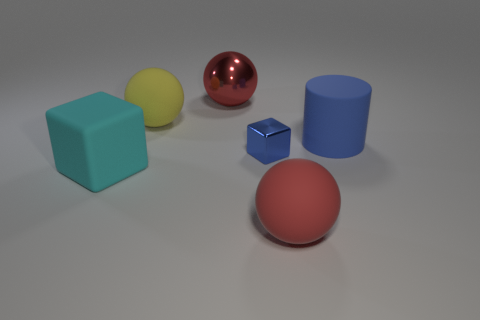Add 1 tiny brown rubber spheres. How many objects exist? 7 Subtract all cylinders. How many objects are left? 5 Subtract all large blue cylinders. Subtract all big blue cylinders. How many objects are left? 4 Add 3 tiny metal things. How many tiny metal things are left? 4 Add 5 blue matte things. How many blue matte things exist? 6 Subtract 0 purple balls. How many objects are left? 6 